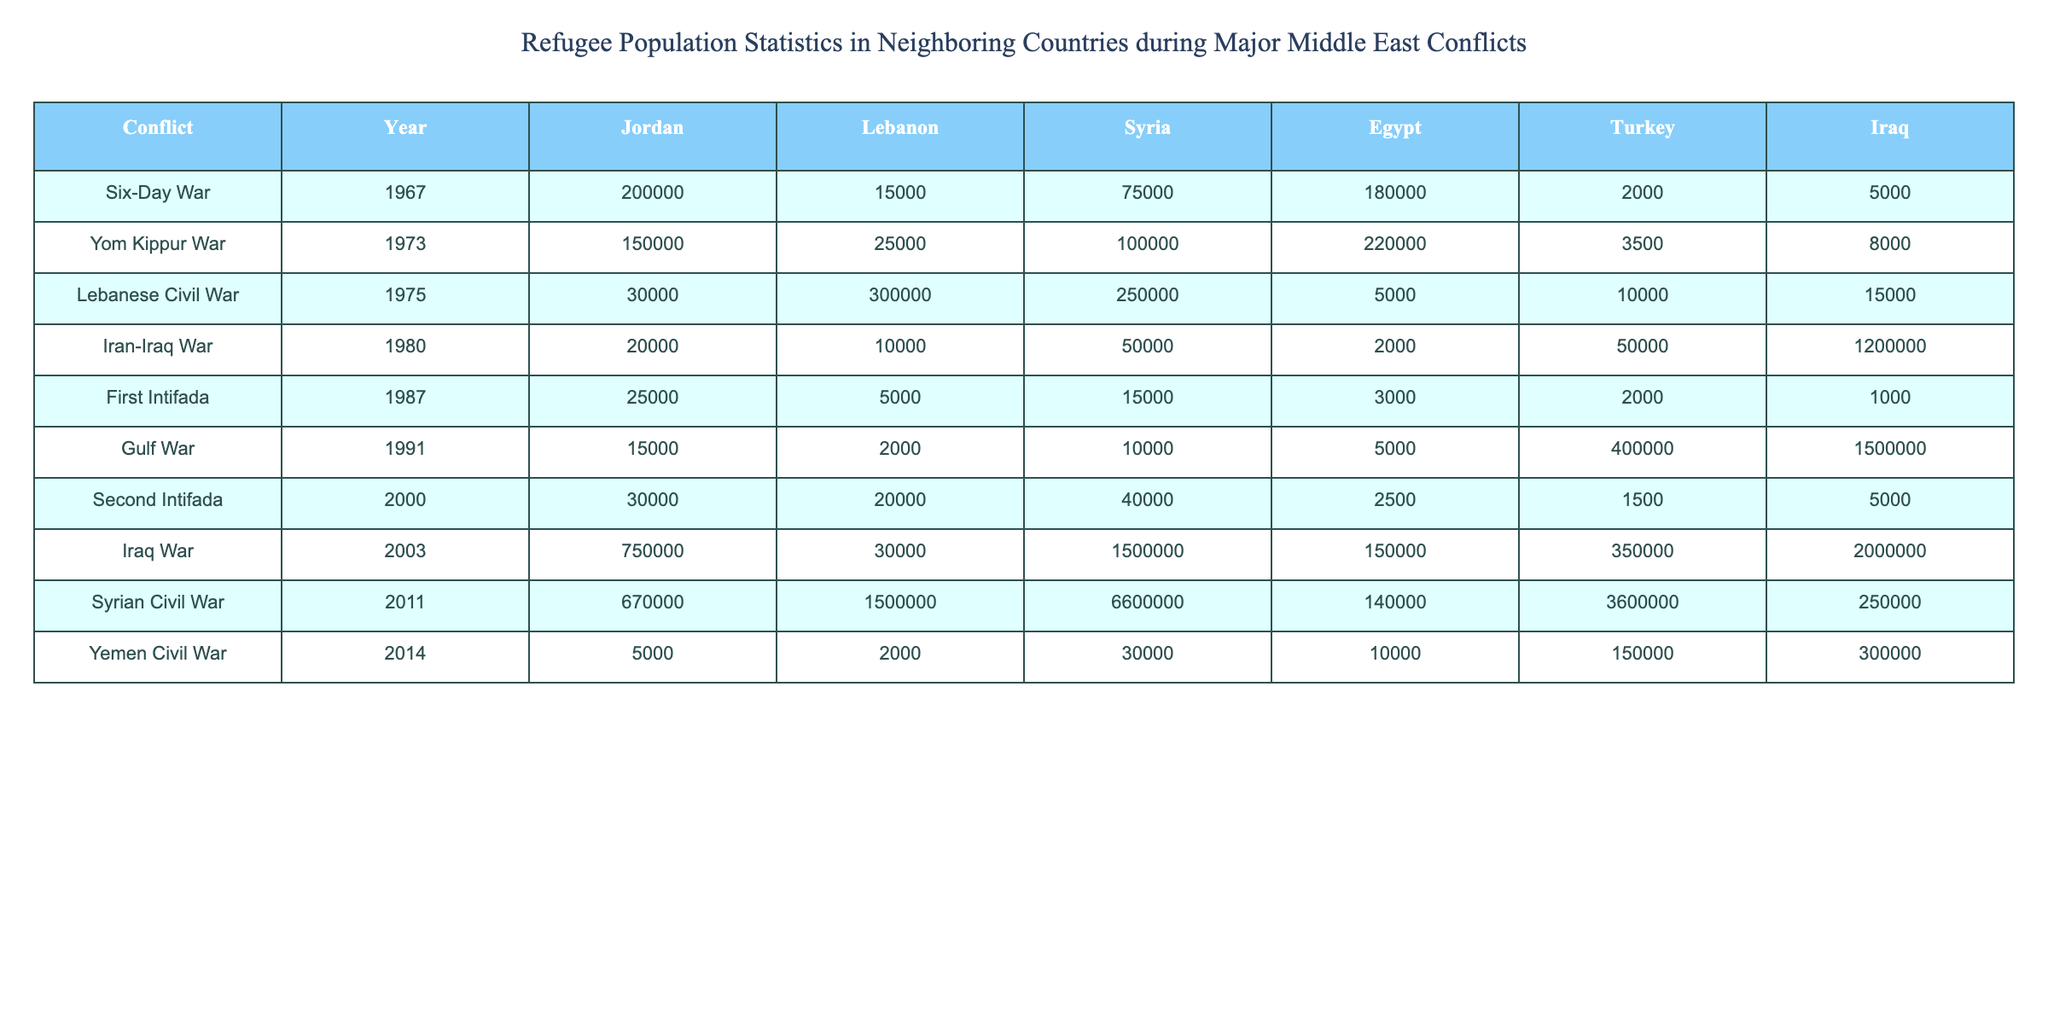What was the total number of refugees in Jordan during the Iraq War? Referring to the table, the number of refugees in Jordan during the Iraq War in 2003 is listed as 750,000.
Answer: 750,000 Which country hosted the highest number of refugees during the Syrian Civil War? Checking the data for the Syrian Civil War in 2011, Syria had 6,600,000 refugees, which is the highest compared to other countries in the table.
Answer: Syria What was the difference in refugee numbers in Lebanon between the Lebanese Civil War and the Second Intifada? In the Lebanese Civil War (1975) Lebanon had 300,000 refugees and in the Second Intifada (2000) it had 20,000. The difference is calculated as 300,000 - 20,000 = 280,000.
Answer: 280,000 Did Egypt have more refugees in 1991 during the Gulf War than in 1987 during the First Intifada? From the table, Egypt had 5,000 refugees during the Gulf War in 1991 and 3,000 during the First Intifada in 1987. Since 5,000 is greater than 3,000, the answer is yes.
Answer: Yes What is the total number of refugees in Turkey from the Iraqi War (2003) and the Syrian Civil War (2011)? The total for Turkey can be calculated by adding the refugees from both conflicts: 350,000 (Iraq War) + 3,600,000 (Syrian Civil War) = 3,950,000.
Answer: 3,950,000 How many total refugees were reported in all countries during the Yom Kippur War? To find the total, we need to add the refugees from all listed countries during the Yom Kippur War in 1973: 150,000 (Jordan) + 25,000 (Lebanon) + 100,000 (Syria) + 220,000 (Egypt) + 3,500 (Turkey) + 8,000 (Iraq) = 506,500.
Answer: 506,500 Which conflict had the largest number of refugees in Syria, and how many were there? According to the table, the Syrian Civil War in 2011 had the highest figure of 6,600,000 refugees in Syria, making it the largest.
Answer: 6,600,000 What percentage of Lebanon's total refugee population during the Lebanese Civil War does the number of refugees during the First Intifada (1987) represent? In Lebanon, there were 300,000 refugees during the Lebanese Civil War and 5,000 during the First Intifada. The percentage is calculated as (5,000 / 300,000) * 100 = 1.67%.
Answer: 1.67% Was there an increase or decrease in the number of refugees in Jordan from the Six-Day War to the Yom Kippur War? In the Six-Day War (1967), Jordan had 200,000 refugees, while during the Yom Kippur War (1973), it had 150,000. Since 150,000 is less than 200,000, this indicates a decrease.
Answer: Decrease Which year saw the largest increase in the refugee population in Iraq compared to the previous conflict listed? By comparing the Iraq War (2003) with the previous conflict (Second Intifada, 2000), the difference is 2,000,000 (Iraq War) - 5,000 (Second Intifada) = 1,995,000, indicating the largest increase in the table.
Answer: 1,995,000 